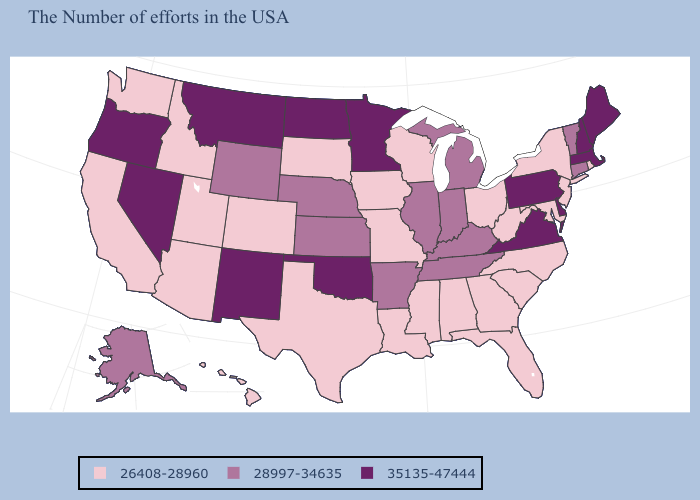Does the map have missing data?
Give a very brief answer. No. Which states have the lowest value in the MidWest?
Answer briefly. Ohio, Wisconsin, Missouri, Iowa, South Dakota. Which states have the highest value in the USA?
Be succinct. Maine, Massachusetts, New Hampshire, Delaware, Pennsylvania, Virginia, Minnesota, Oklahoma, North Dakota, New Mexico, Montana, Nevada, Oregon. Does New York have the same value as Utah?
Give a very brief answer. Yes. Does Virginia have the highest value in the South?
Quick response, please. Yes. Name the states that have a value in the range 26408-28960?
Answer briefly. Rhode Island, New York, New Jersey, Maryland, North Carolina, South Carolina, West Virginia, Ohio, Florida, Georgia, Alabama, Wisconsin, Mississippi, Louisiana, Missouri, Iowa, Texas, South Dakota, Colorado, Utah, Arizona, Idaho, California, Washington, Hawaii. What is the highest value in the USA?
Short answer required. 35135-47444. What is the lowest value in the West?
Short answer required. 26408-28960. What is the highest value in the USA?
Answer briefly. 35135-47444. Name the states that have a value in the range 28997-34635?
Answer briefly. Vermont, Connecticut, Michigan, Kentucky, Indiana, Tennessee, Illinois, Arkansas, Kansas, Nebraska, Wyoming, Alaska. Name the states that have a value in the range 26408-28960?
Quick response, please. Rhode Island, New York, New Jersey, Maryland, North Carolina, South Carolina, West Virginia, Ohio, Florida, Georgia, Alabama, Wisconsin, Mississippi, Louisiana, Missouri, Iowa, Texas, South Dakota, Colorado, Utah, Arizona, Idaho, California, Washington, Hawaii. What is the value of Maine?
Short answer required. 35135-47444. What is the lowest value in the South?
Quick response, please. 26408-28960. Name the states that have a value in the range 26408-28960?
Concise answer only. Rhode Island, New York, New Jersey, Maryland, North Carolina, South Carolina, West Virginia, Ohio, Florida, Georgia, Alabama, Wisconsin, Mississippi, Louisiana, Missouri, Iowa, Texas, South Dakota, Colorado, Utah, Arizona, Idaho, California, Washington, Hawaii. What is the highest value in the USA?
Give a very brief answer. 35135-47444. 